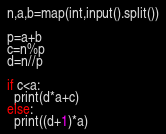<code> <loc_0><loc_0><loc_500><loc_500><_Python_>n,a,b=map(int,input().split())

p=a+b
c=n%p
d=n//p

if c<a:
  print(d*a+c)
else:
  print((d+1)*a)</code> 